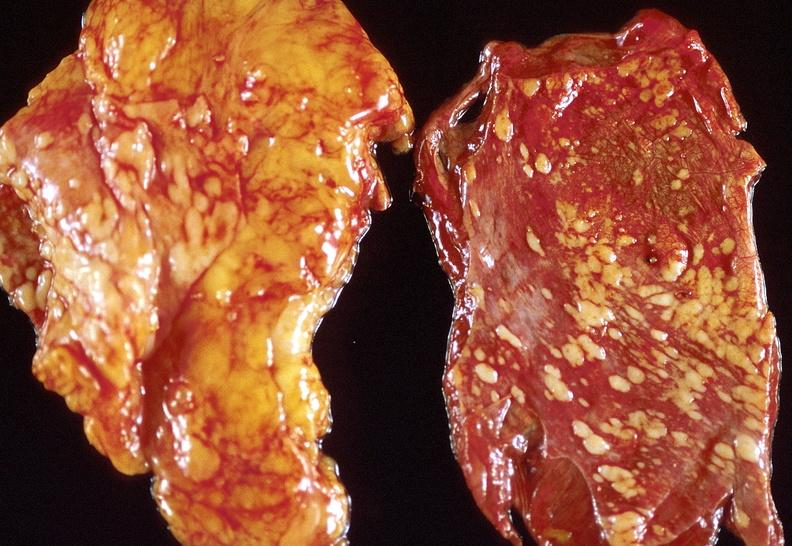s metastatic malignant melanoma present?
Answer the question using a single word or phrase. No 